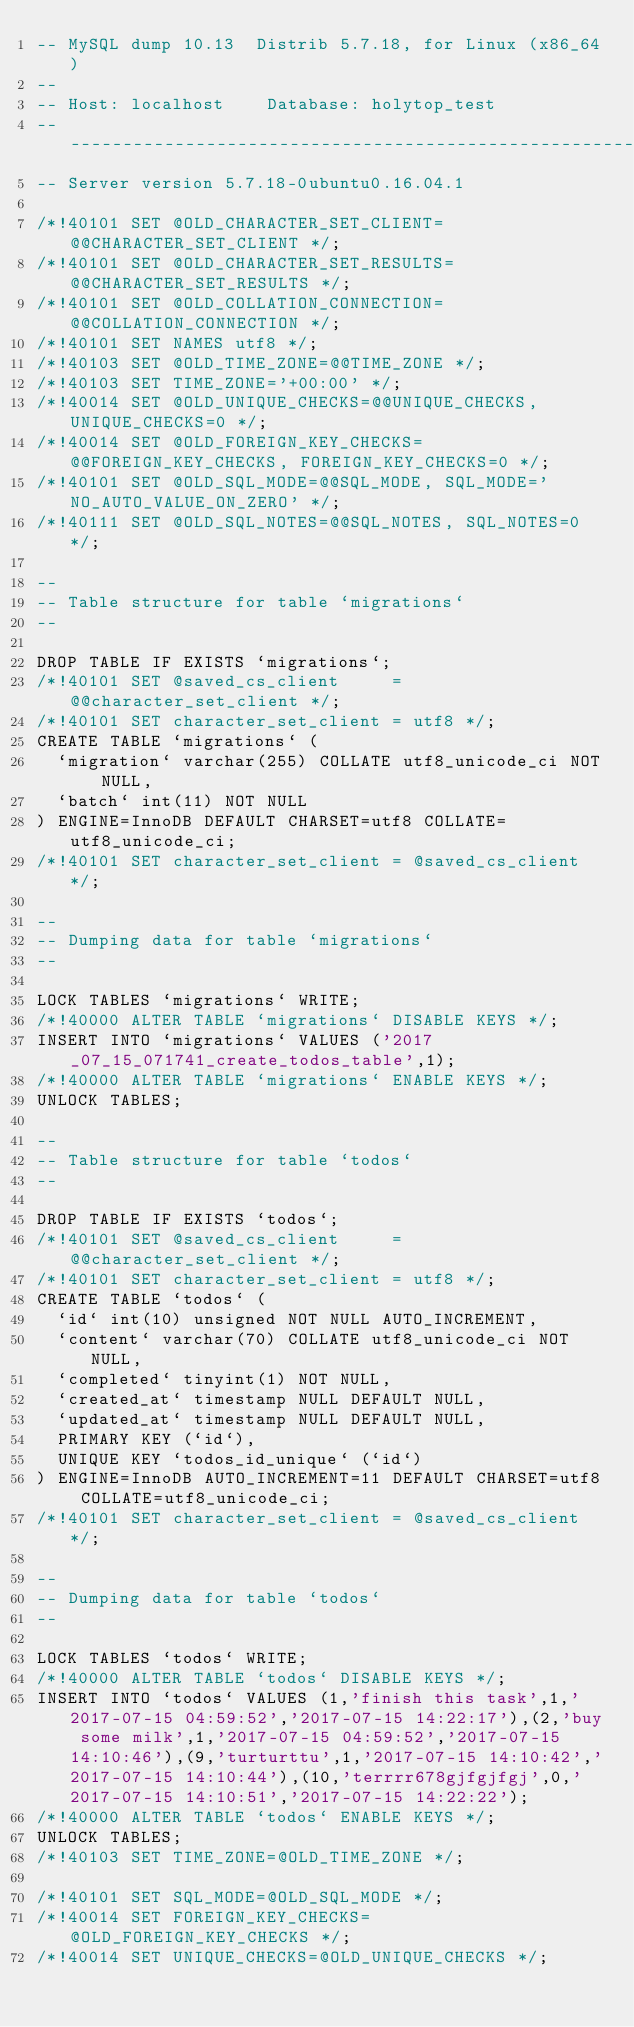<code> <loc_0><loc_0><loc_500><loc_500><_SQL_>-- MySQL dump 10.13  Distrib 5.7.18, for Linux (x86_64)
--
-- Host: localhost    Database: holytop_test
-- ------------------------------------------------------
-- Server version	5.7.18-0ubuntu0.16.04.1

/*!40101 SET @OLD_CHARACTER_SET_CLIENT=@@CHARACTER_SET_CLIENT */;
/*!40101 SET @OLD_CHARACTER_SET_RESULTS=@@CHARACTER_SET_RESULTS */;
/*!40101 SET @OLD_COLLATION_CONNECTION=@@COLLATION_CONNECTION */;
/*!40101 SET NAMES utf8 */;
/*!40103 SET @OLD_TIME_ZONE=@@TIME_ZONE */;
/*!40103 SET TIME_ZONE='+00:00' */;
/*!40014 SET @OLD_UNIQUE_CHECKS=@@UNIQUE_CHECKS, UNIQUE_CHECKS=0 */;
/*!40014 SET @OLD_FOREIGN_KEY_CHECKS=@@FOREIGN_KEY_CHECKS, FOREIGN_KEY_CHECKS=0 */;
/*!40101 SET @OLD_SQL_MODE=@@SQL_MODE, SQL_MODE='NO_AUTO_VALUE_ON_ZERO' */;
/*!40111 SET @OLD_SQL_NOTES=@@SQL_NOTES, SQL_NOTES=0 */;

--
-- Table structure for table `migrations`
--

DROP TABLE IF EXISTS `migrations`;
/*!40101 SET @saved_cs_client     = @@character_set_client */;
/*!40101 SET character_set_client = utf8 */;
CREATE TABLE `migrations` (
  `migration` varchar(255) COLLATE utf8_unicode_ci NOT NULL,
  `batch` int(11) NOT NULL
) ENGINE=InnoDB DEFAULT CHARSET=utf8 COLLATE=utf8_unicode_ci;
/*!40101 SET character_set_client = @saved_cs_client */;

--
-- Dumping data for table `migrations`
--

LOCK TABLES `migrations` WRITE;
/*!40000 ALTER TABLE `migrations` DISABLE KEYS */;
INSERT INTO `migrations` VALUES ('2017_07_15_071741_create_todos_table',1);
/*!40000 ALTER TABLE `migrations` ENABLE KEYS */;
UNLOCK TABLES;

--
-- Table structure for table `todos`
--

DROP TABLE IF EXISTS `todos`;
/*!40101 SET @saved_cs_client     = @@character_set_client */;
/*!40101 SET character_set_client = utf8 */;
CREATE TABLE `todos` (
  `id` int(10) unsigned NOT NULL AUTO_INCREMENT,
  `content` varchar(70) COLLATE utf8_unicode_ci NOT NULL,
  `completed` tinyint(1) NOT NULL,
  `created_at` timestamp NULL DEFAULT NULL,
  `updated_at` timestamp NULL DEFAULT NULL,
  PRIMARY KEY (`id`),
  UNIQUE KEY `todos_id_unique` (`id`)
) ENGINE=InnoDB AUTO_INCREMENT=11 DEFAULT CHARSET=utf8 COLLATE=utf8_unicode_ci;
/*!40101 SET character_set_client = @saved_cs_client */;

--
-- Dumping data for table `todos`
--

LOCK TABLES `todos` WRITE;
/*!40000 ALTER TABLE `todos` DISABLE KEYS */;
INSERT INTO `todos` VALUES (1,'finish this task',1,'2017-07-15 04:59:52','2017-07-15 14:22:17'),(2,'buy some milk',1,'2017-07-15 04:59:52','2017-07-15 14:10:46'),(9,'turturttu',1,'2017-07-15 14:10:42','2017-07-15 14:10:44'),(10,'terrrr678gjfgjfgj',0,'2017-07-15 14:10:51','2017-07-15 14:22:22');
/*!40000 ALTER TABLE `todos` ENABLE KEYS */;
UNLOCK TABLES;
/*!40103 SET TIME_ZONE=@OLD_TIME_ZONE */;

/*!40101 SET SQL_MODE=@OLD_SQL_MODE */;
/*!40014 SET FOREIGN_KEY_CHECKS=@OLD_FOREIGN_KEY_CHECKS */;
/*!40014 SET UNIQUE_CHECKS=@OLD_UNIQUE_CHECKS */;</code> 